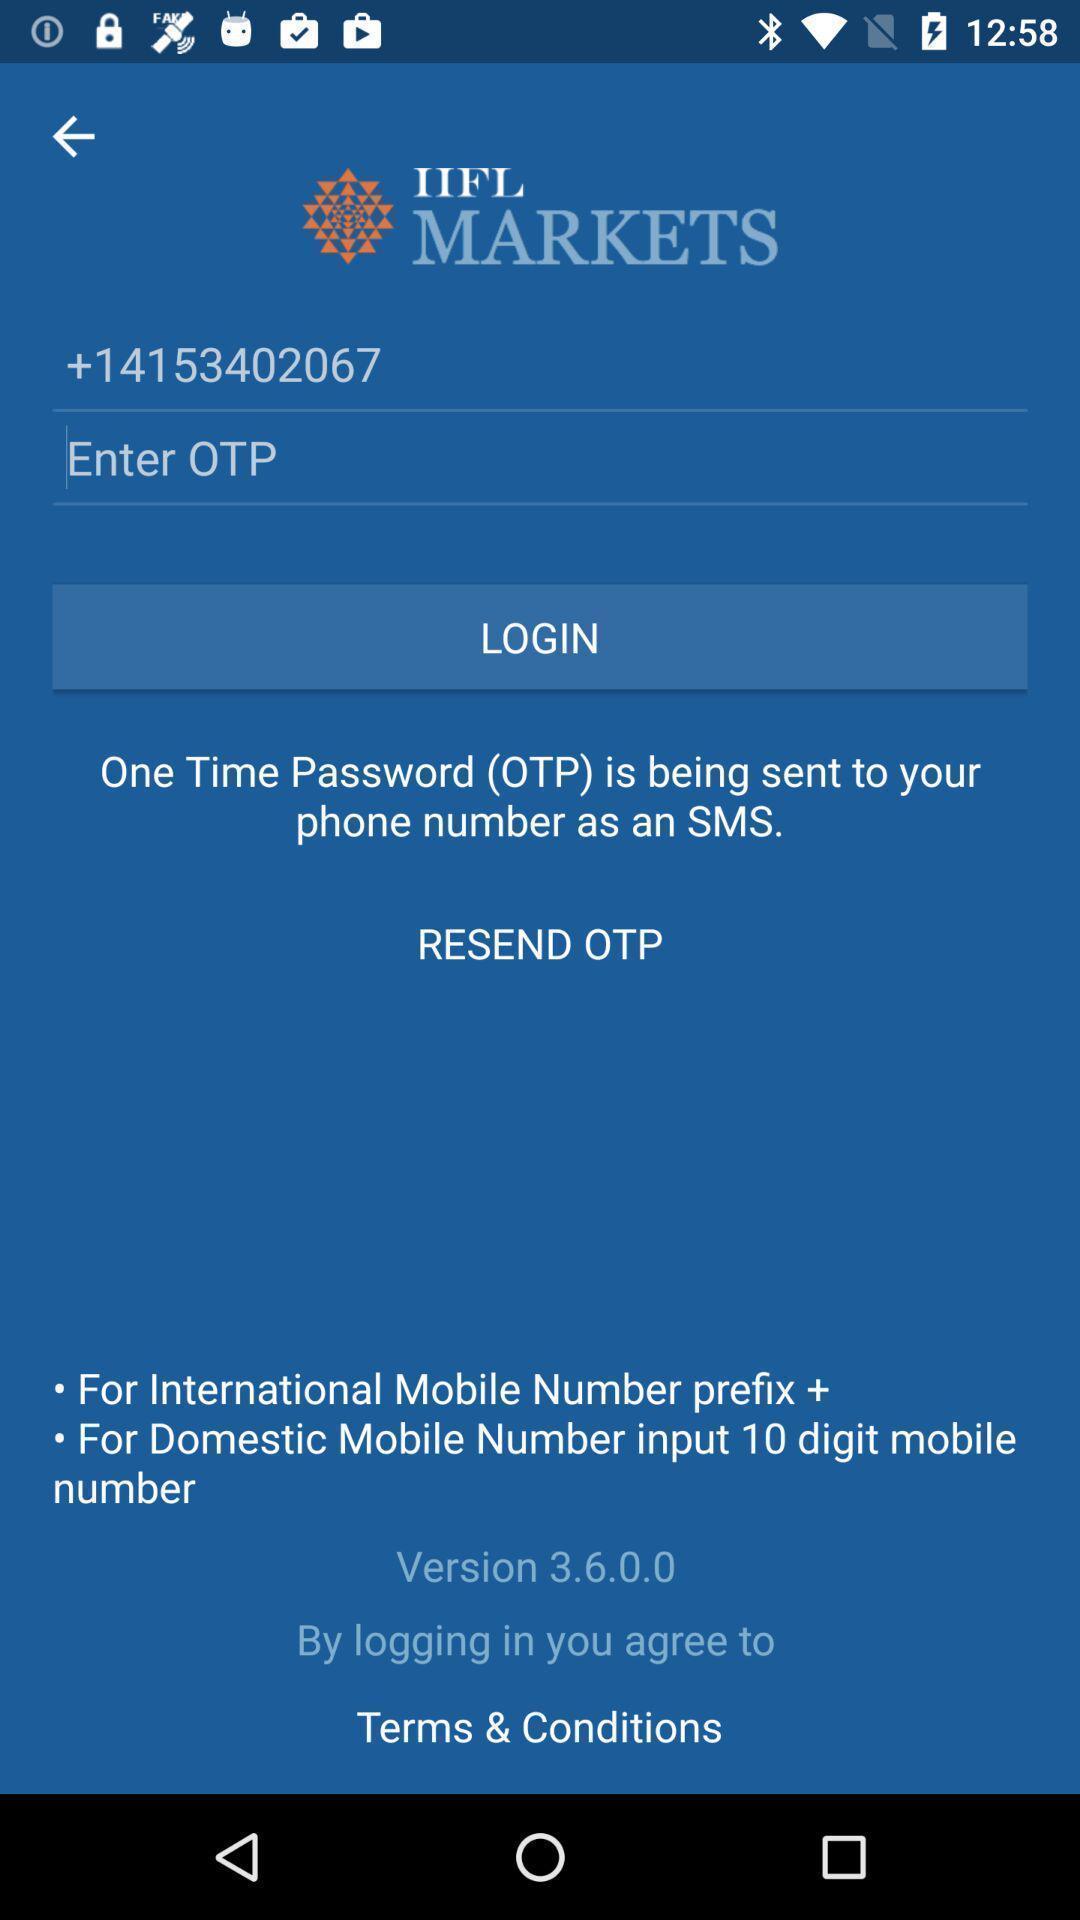What can you discern from this picture? Login page of a social app. 